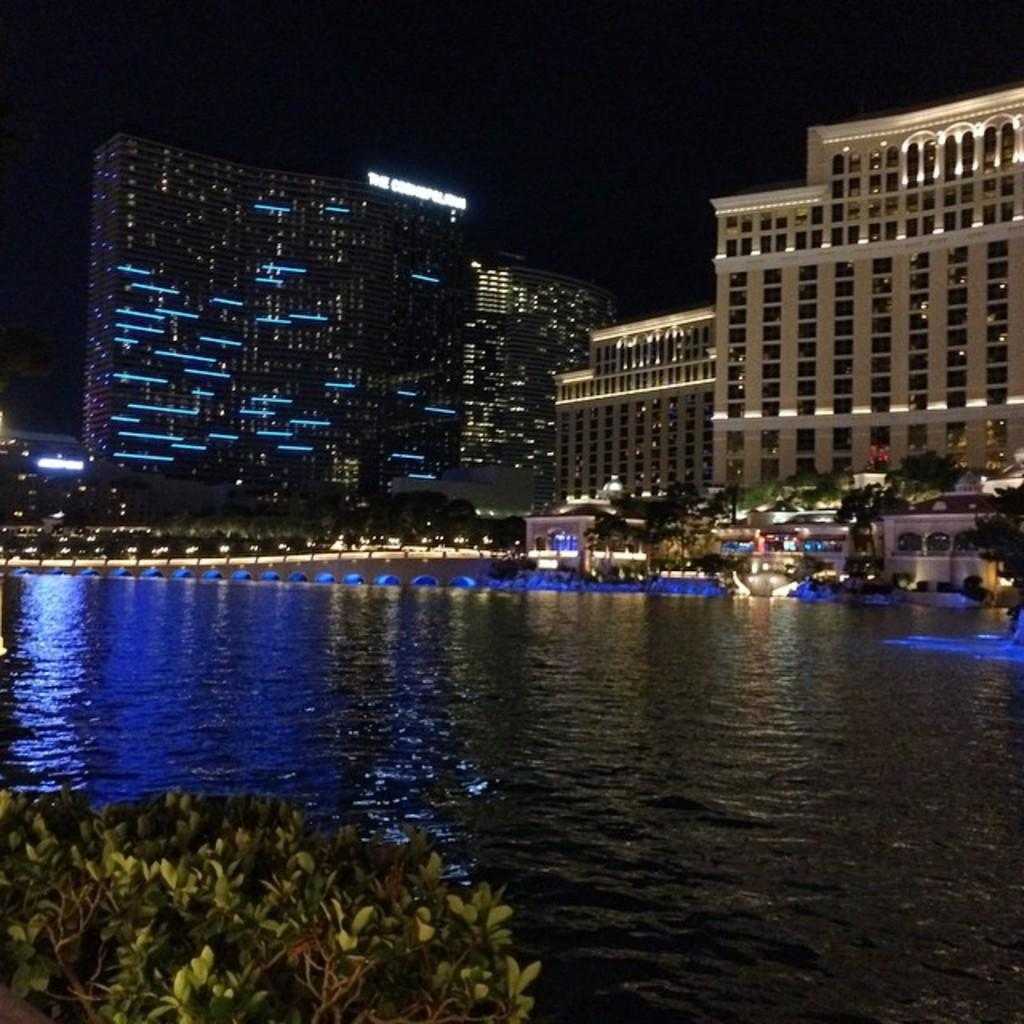What is the lighting condition in the image? The image was taken in the dark. What can be seen at the bottom of the image? There is water visible at the bottom of the image. What is located near the water? There are plants near the water. What can be seen in the distance in the image? There are many buildings and lights in the background of the image, as well as trees. What mathematical operation is being performed by the group of people in the image? There is no group of people performing any mathematical operation in the image. What is the wealth status of the plants near the water? The wealth status of the plants cannot be determined from the image, as plants do not have a wealth status. 